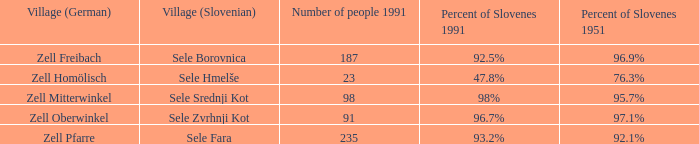What is the name of the german village where 96.9% of the population were slovenes in 1951? Zell Freibach. 